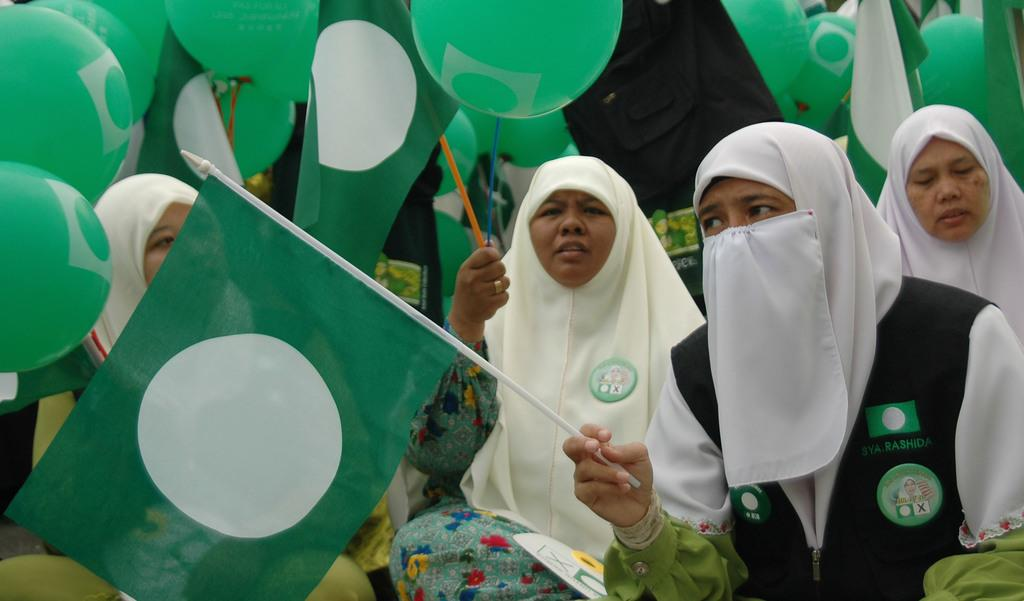What is the main subject of the image? The main subject of the image is a group of women. What are the women holding in the image? The women are holding green color flags and balloons. What can be seen on the women's heads in the image? The women are wearing white color hijabs. Can you tell me how many bombs are visible in the image? There are no bombs present in the image; it features a group of women holding flags and balloons. What type of scarf is the woman wearing in the image? The women are wearing white color hijabs, which are not specifically referred to as scarves in the image. 